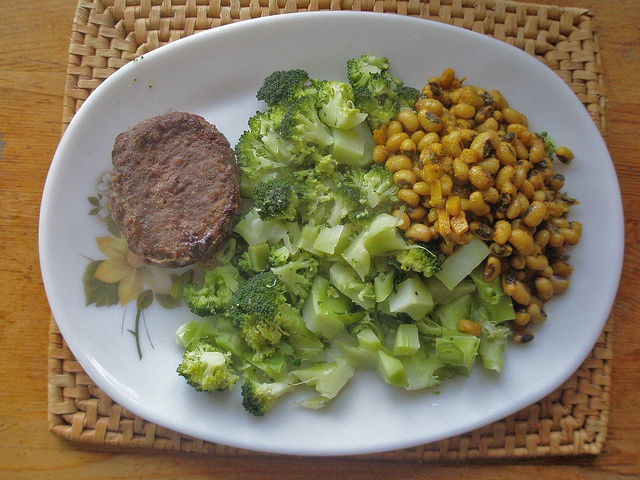Describe the objects in this image and their specific colors. I can see broccoli in olive and darkgreen tones, broccoli in olive and darkgreen tones, broccoli in olive and darkgreen tones, broccoli in olive and darkgreen tones, and broccoli in olive and darkgreen tones in this image. 